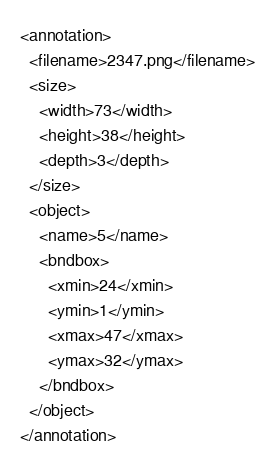Convert code to text. <code><loc_0><loc_0><loc_500><loc_500><_XML_><annotation>
  <filename>2347.png</filename>
  <size>
    <width>73</width>
    <height>38</height>
    <depth>3</depth>
  </size>
  <object>
    <name>5</name>
    <bndbox>
      <xmin>24</xmin>
      <ymin>1</ymin>
      <xmax>47</xmax>
      <ymax>32</ymax>
    </bndbox>
  </object>
</annotation>
</code> 